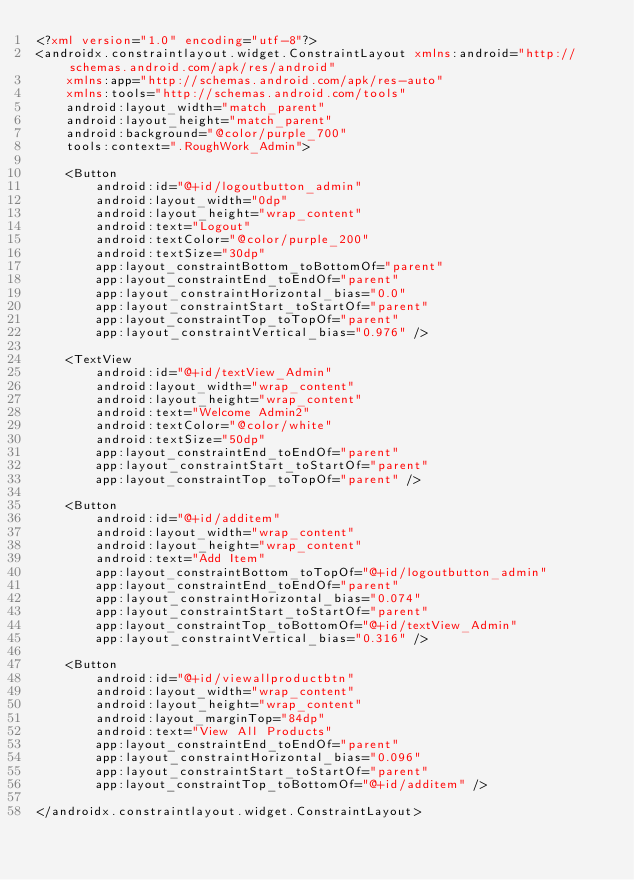<code> <loc_0><loc_0><loc_500><loc_500><_XML_><?xml version="1.0" encoding="utf-8"?>
<androidx.constraintlayout.widget.ConstraintLayout xmlns:android="http://schemas.android.com/apk/res/android"
    xmlns:app="http://schemas.android.com/apk/res-auto"
    xmlns:tools="http://schemas.android.com/tools"
    android:layout_width="match_parent"
    android:layout_height="match_parent"
    android:background="@color/purple_700"
    tools:context=".RoughWork_Admin">

    <Button
        android:id="@+id/logoutbutton_admin"
        android:layout_width="0dp"
        android:layout_height="wrap_content"
        android:text="Logout"
        android:textColor="@color/purple_200"
        android:textSize="30dp"
        app:layout_constraintBottom_toBottomOf="parent"
        app:layout_constraintEnd_toEndOf="parent"
        app:layout_constraintHorizontal_bias="0.0"
        app:layout_constraintStart_toStartOf="parent"
        app:layout_constraintTop_toTopOf="parent"
        app:layout_constraintVertical_bias="0.976" />

    <TextView
        android:id="@+id/textView_Admin"
        android:layout_width="wrap_content"
        android:layout_height="wrap_content"
        android:text="Welcome Admin2"
        android:textColor="@color/white"
        android:textSize="50dp"
        app:layout_constraintEnd_toEndOf="parent"
        app:layout_constraintStart_toStartOf="parent"
        app:layout_constraintTop_toTopOf="parent" />

    <Button
        android:id="@+id/additem"
        android:layout_width="wrap_content"
        android:layout_height="wrap_content"
        android:text="Add Item"
        app:layout_constraintBottom_toTopOf="@+id/logoutbutton_admin"
        app:layout_constraintEnd_toEndOf="parent"
        app:layout_constraintHorizontal_bias="0.074"
        app:layout_constraintStart_toStartOf="parent"
        app:layout_constraintTop_toBottomOf="@+id/textView_Admin"
        app:layout_constraintVertical_bias="0.316" />

    <Button
        android:id="@+id/viewallproductbtn"
        android:layout_width="wrap_content"
        android:layout_height="wrap_content"
        android:layout_marginTop="84dp"
        android:text="View All Products"
        app:layout_constraintEnd_toEndOf="parent"
        app:layout_constraintHorizontal_bias="0.096"
        app:layout_constraintStart_toStartOf="parent"
        app:layout_constraintTop_toBottomOf="@+id/additem" />

</androidx.constraintlayout.widget.ConstraintLayout></code> 